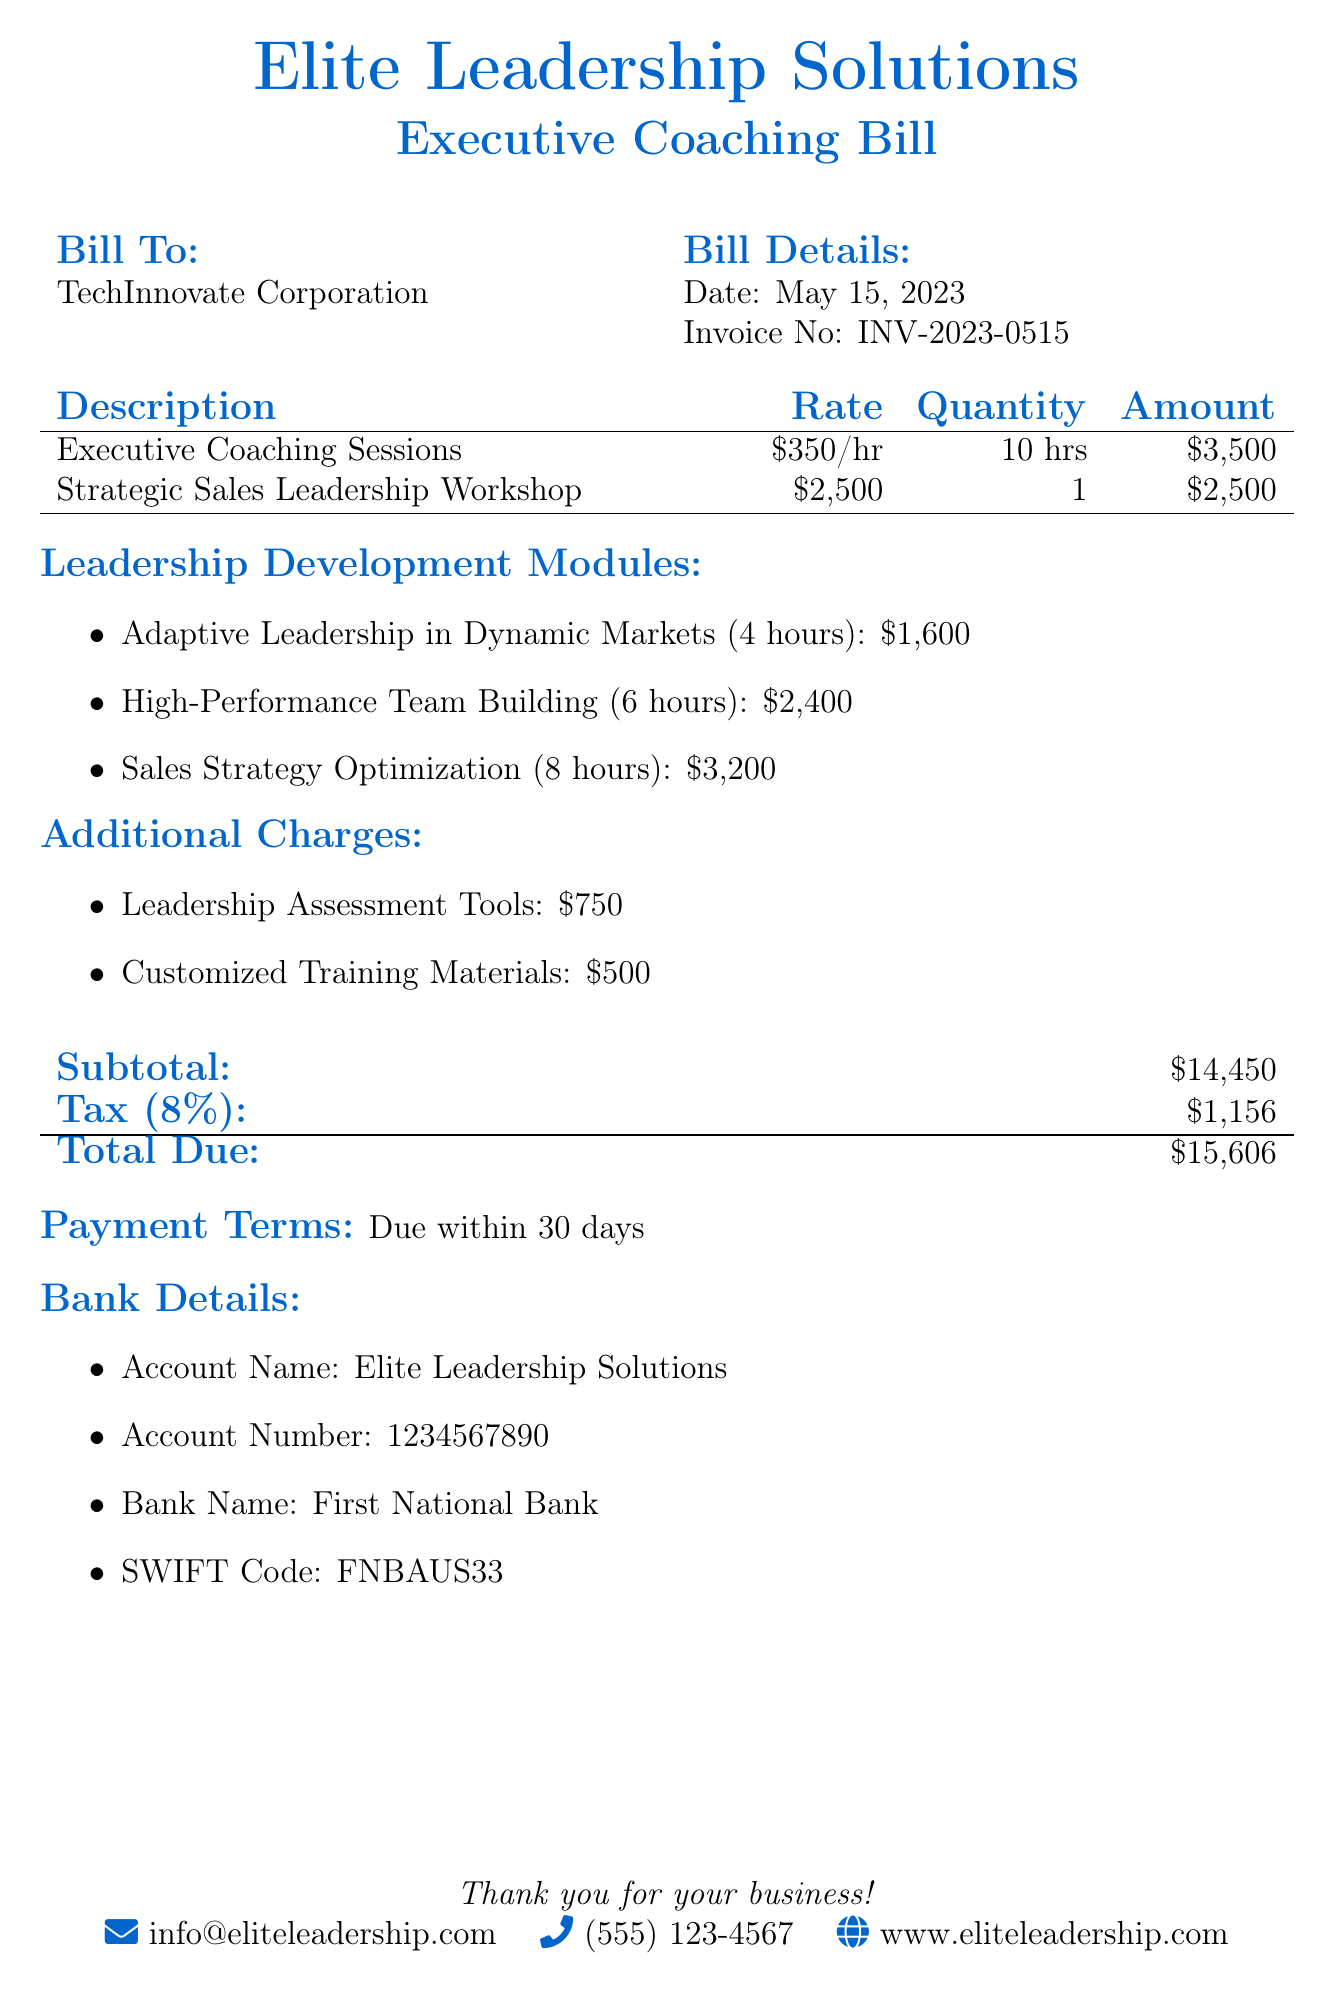What is the invoice number? The invoice number is provided in the document as a specific identifier for the bill, which is INV-2023-0515.
Answer: INV-2023-0515 What is the date of the invoice? The date of the invoice is explicitly stated in the document, which is May 15, 2023.
Answer: May 15, 2023 How many hours are allocated for executive coaching sessions? The total hours for executive coaching sessions are mentioned in the bill, which is 10 hours.
Answer: 10 hrs What is the rate for the Strategic Sales Leadership Workshop? The document specifies the rate for this workshop, which is $2,500.
Answer: $2,500 What is the total amount due for the bill? The total amount due is clearly stated at the end of the document, detailing the grand total.
Answer: $15,606 How much do the leadership assessment tools cost? The cost for the leadership assessment tools is listed in the additional charges section, which is $750.
Answer: $750 What is the subtotal before tax? The subtotal before tax is explicitly mentioned in the document, which shows the amount calculated prior to adding tax.
Answer: $14,450 How many leadership development modules are listed? The document provides a list of leadership development modules, which includes three specific modules mentioned.
Answer: 3 modules What are the payment terms indicated in the document? Payment terms outline when payment is due, which is provided in the document as due within 30 days.
Answer: Due within 30 days 